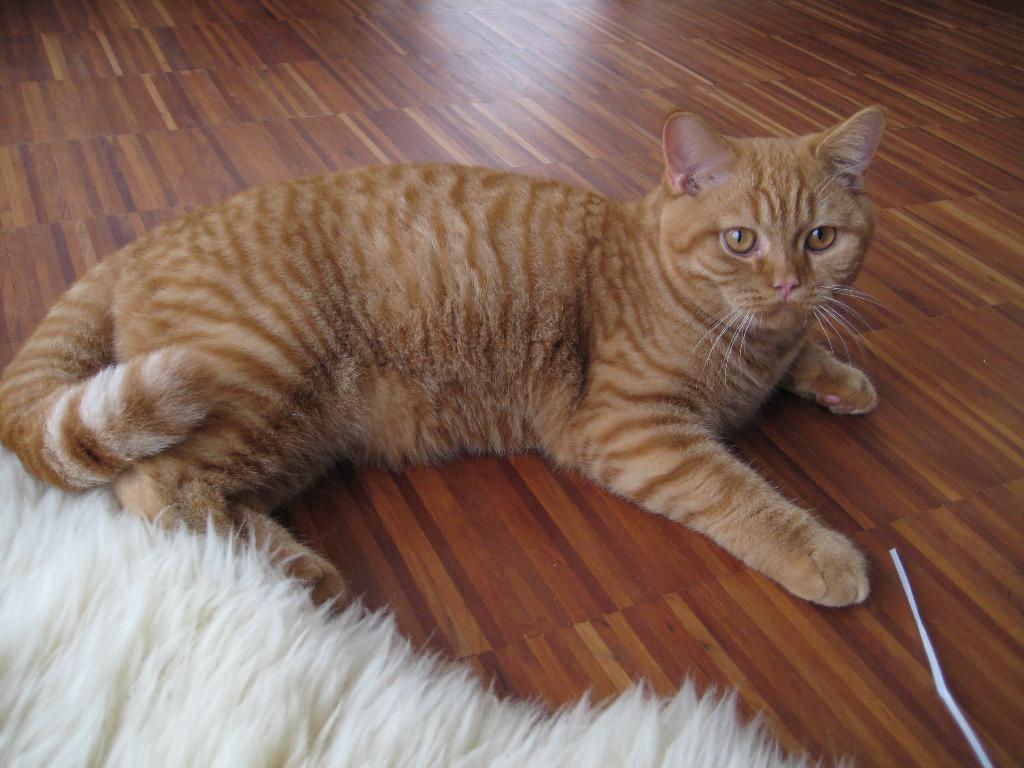Describe this image in one or two sentences. In this image we can see cat on the floor. 